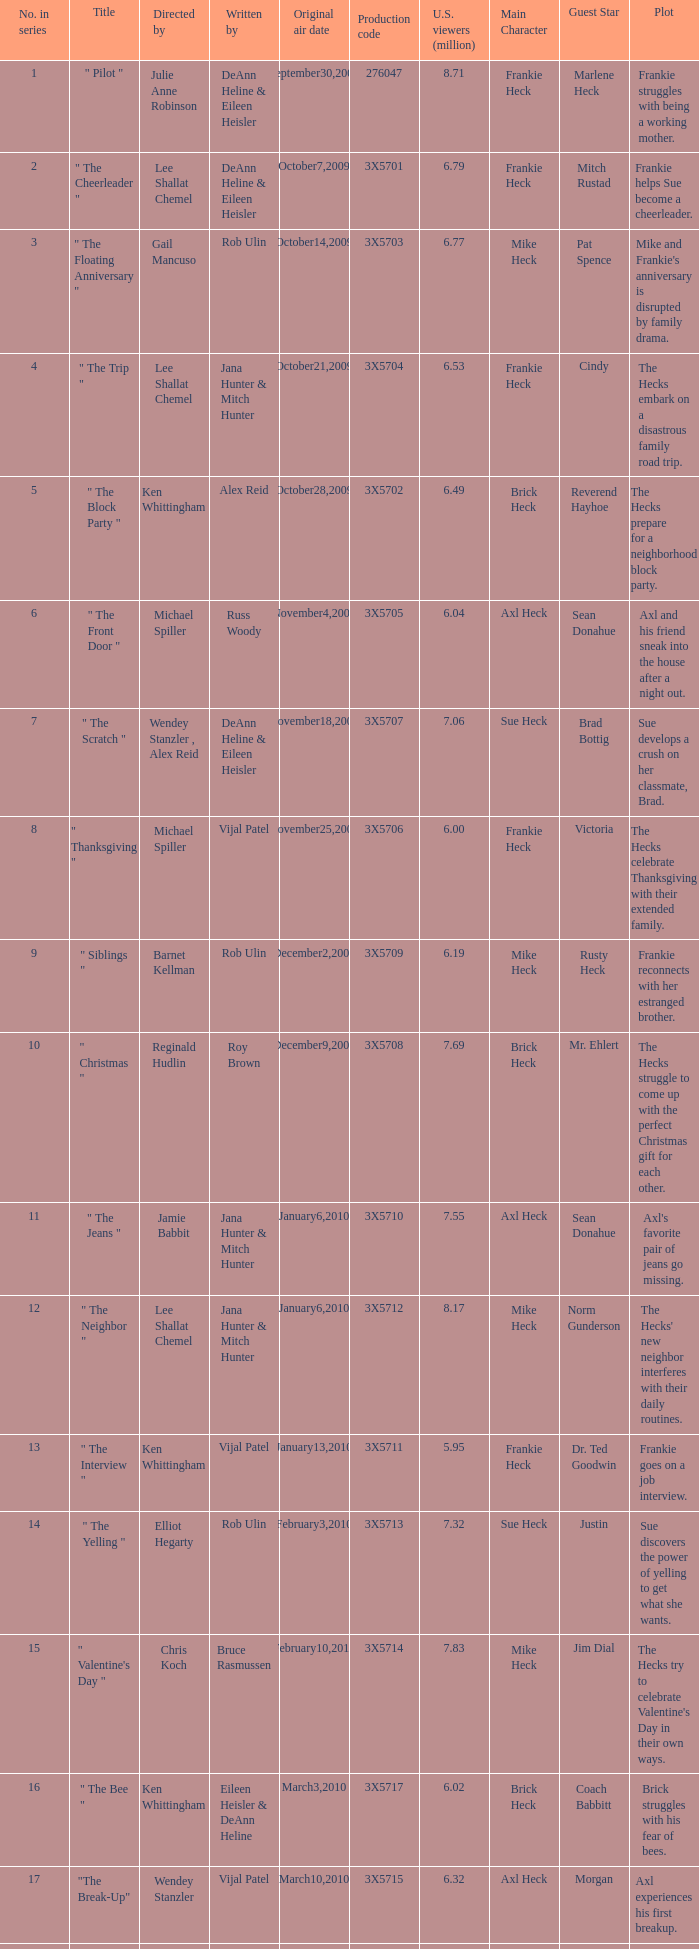95 million u.s. viewers? Vijal Patel. 